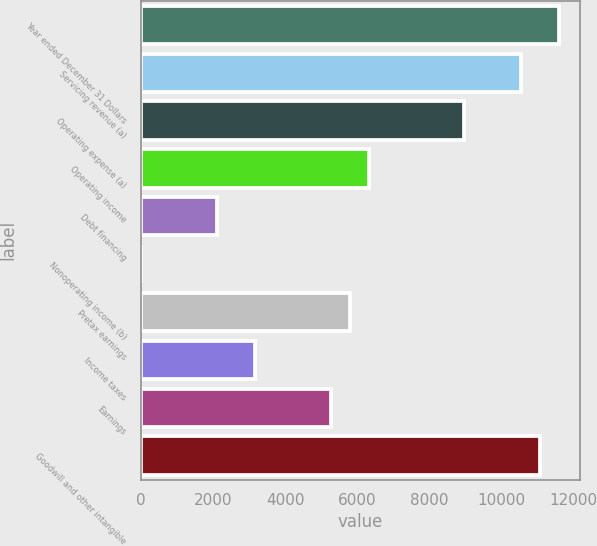Convert chart to OTSL. <chart><loc_0><loc_0><loc_500><loc_500><bar_chart><fcel>Year ended December 31 Dollars<fcel>Servicing revenue (a)<fcel>Operating expense (a)<fcel>Operating income<fcel>Debt financing<fcel>Nonoperating income (b)<fcel>Pretax earnings<fcel>Income taxes<fcel>Earnings<fcel>Goodwill and other intangible<nl><fcel>11608<fcel>10553<fcel>8970.5<fcel>6333<fcel>2113<fcel>3<fcel>5805.5<fcel>3168<fcel>5278<fcel>11080.5<nl></chart> 